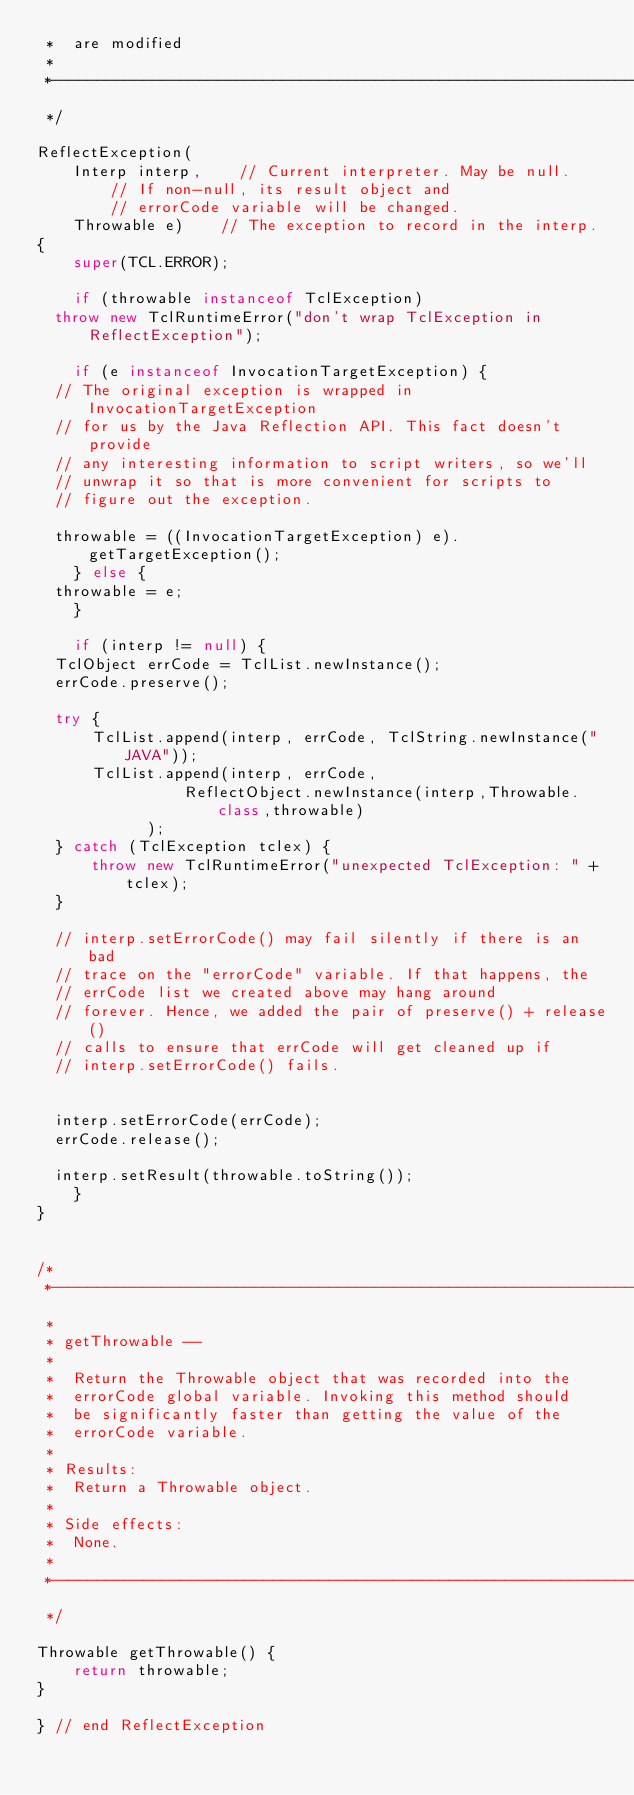<code> <loc_0><loc_0><loc_500><loc_500><_Java_> *	are modified
 *
 *----------------------------------------------------------------------
 */

ReflectException(
    Interp interp,		// Current interpreter. May be null.
				// If non-null, its result object and
				// errorCode variable will be changed.
    Throwable e)		// The exception to record in the interp.
{
    super(TCL.ERROR);

    if (throwable instanceof TclException)
	throw new TclRuntimeError("don't wrap TclException in ReflectException");

    if (e instanceof InvocationTargetException) {
	// The original exception is wrapped in InvocationTargetException
	// for us by the Java Reflection API. This fact doesn't provide
	// any interesting information to script writers, so we'll
	// unwrap it so that is more convenient for scripts to
	// figure out the exception.

	throwable = ((InvocationTargetException) e).getTargetException();
    } else {
	throwable = e;
    }

    if (interp != null) {
	TclObject errCode = TclList.newInstance();
	errCode.preserve();

	try {
	    TclList.append(interp, errCode, TclString.newInstance("JAVA"));
	    TclList.append(interp, errCode,
                ReflectObject.newInstance(interp,Throwable.class,throwable)
            );
	} catch (TclException tclex) {
	    throw new TclRuntimeError("unexpected TclException: " + tclex);
	}

	// interp.setErrorCode() may fail silently if there is an bad
	// trace on the "errorCode" variable. If that happens, the
	// errCode list we created above may hang around
	// forever. Hence, we added the pair of preserve() + release()
	// calls to ensure that errCode will get cleaned up if
	// interp.setErrorCode() fails.


	interp.setErrorCode(errCode);
	errCode.release();

	interp.setResult(throwable.toString());
    }
}

/*
 *----------------------------------------------------------------------
 *
 * getThrowable --
 *
 *	Return the Throwable object that was recorded into the
 *	errorCode global variable. Invoking this method should
 *	be significantly faster than getting the value of the
 *	errorCode variable.
 *
 * Results:
 * 	Return a Throwable object.
 *
 * Side effects:
 *	None.
 *
 *----------------------------------------------------------------------
 */

Throwable getThrowable() {
    return throwable;
}

} // end ReflectException

</code> 